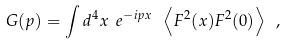<formula> <loc_0><loc_0><loc_500><loc_500>G ( p ) = \int d ^ { 4 } x \ e ^ { - i p x \ } \left \langle F ^ { 2 } ( x ) F ^ { 2 } ( 0 ) \right \rangle \ ,</formula> 